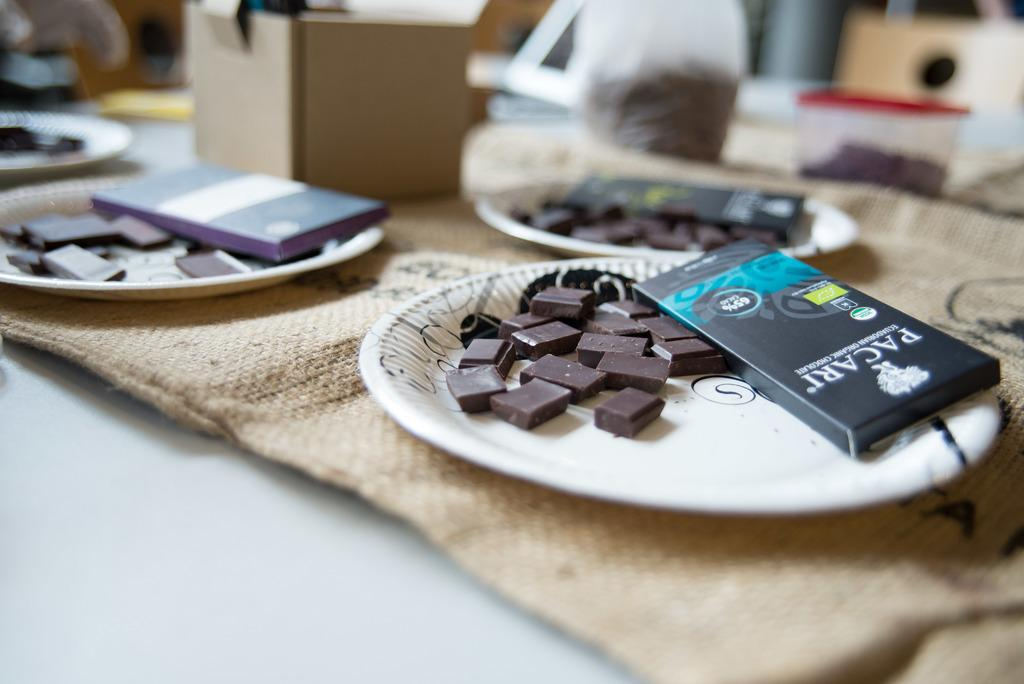Provide a one-sentence caption for the provided image. A box of chocolate from Pacari lays on a paper plate along side some chocolate squares. 